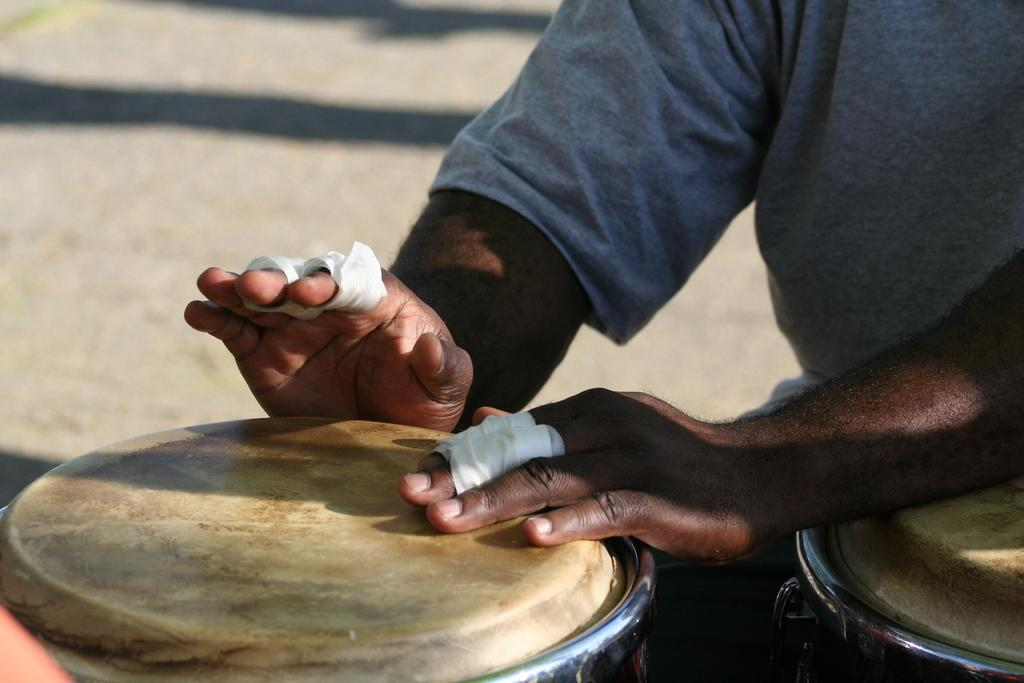What is the main subject of the image? The main subject of the image is a man. What is the man doing in the image? The man is beating drums. What is the man wearing in the image? The man is wearing a t-shirt. What type of thread is being used to sew the roof in the image? There is no roof or thread present in the image; it features a man beating drums while wearing a t-shirt. 